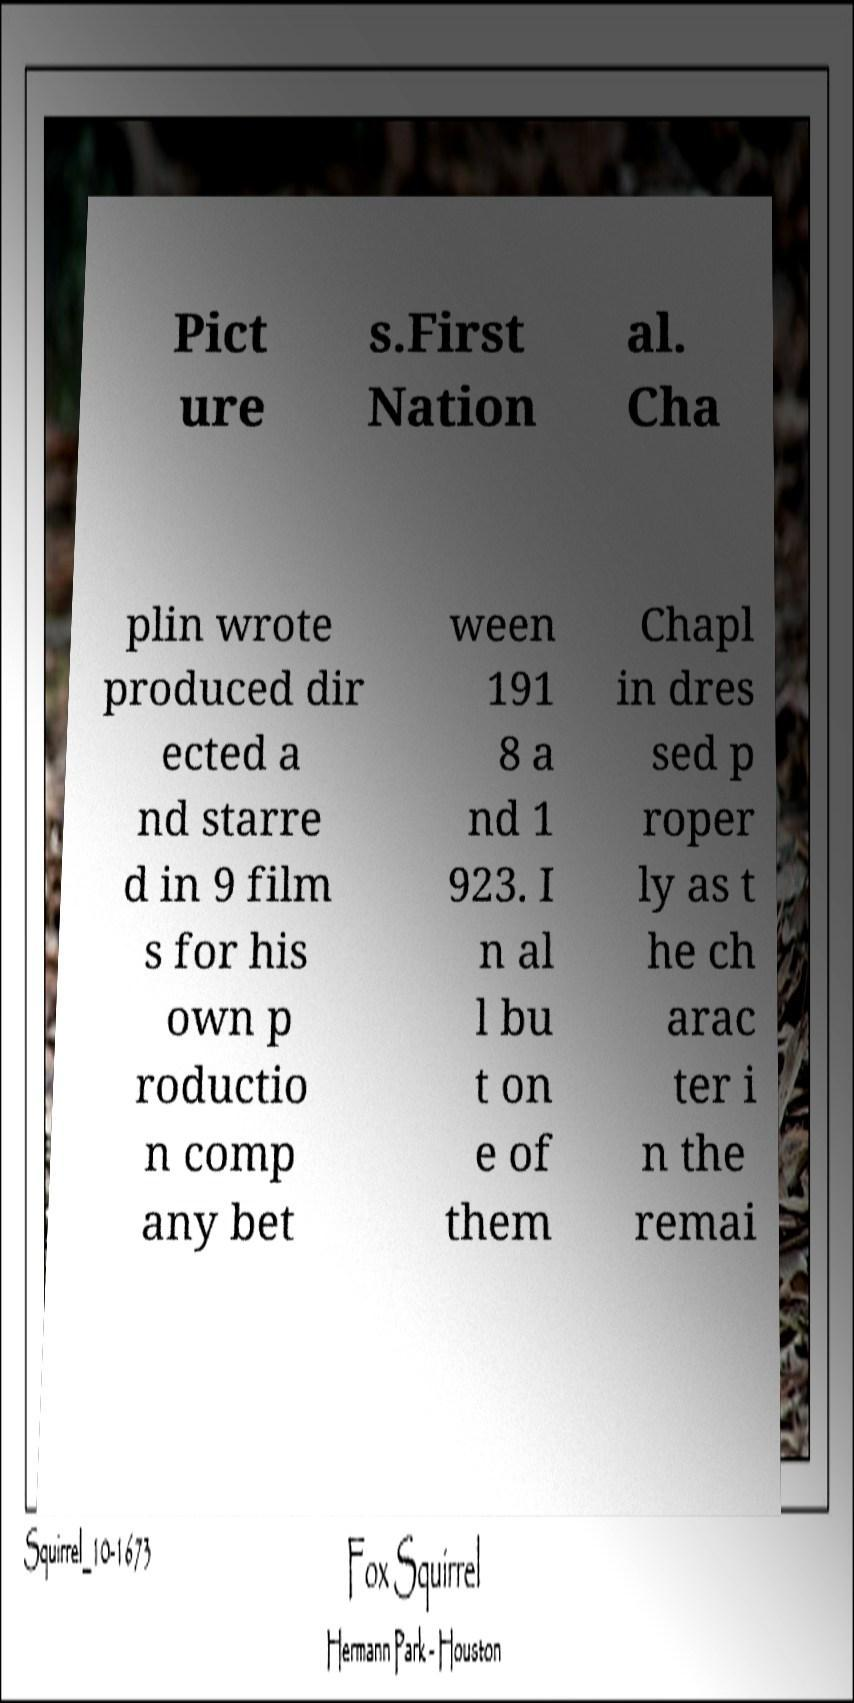There's text embedded in this image that I need extracted. Can you transcribe it verbatim? Pict ure s.First Nation al. Cha plin wrote produced dir ected a nd starre d in 9 film s for his own p roductio n comp any bet ween 191 8 a nd 1 923. I n al l bu t on e of them Chapl in dres sed p roper ly as t he ch arac ter i n the remai 